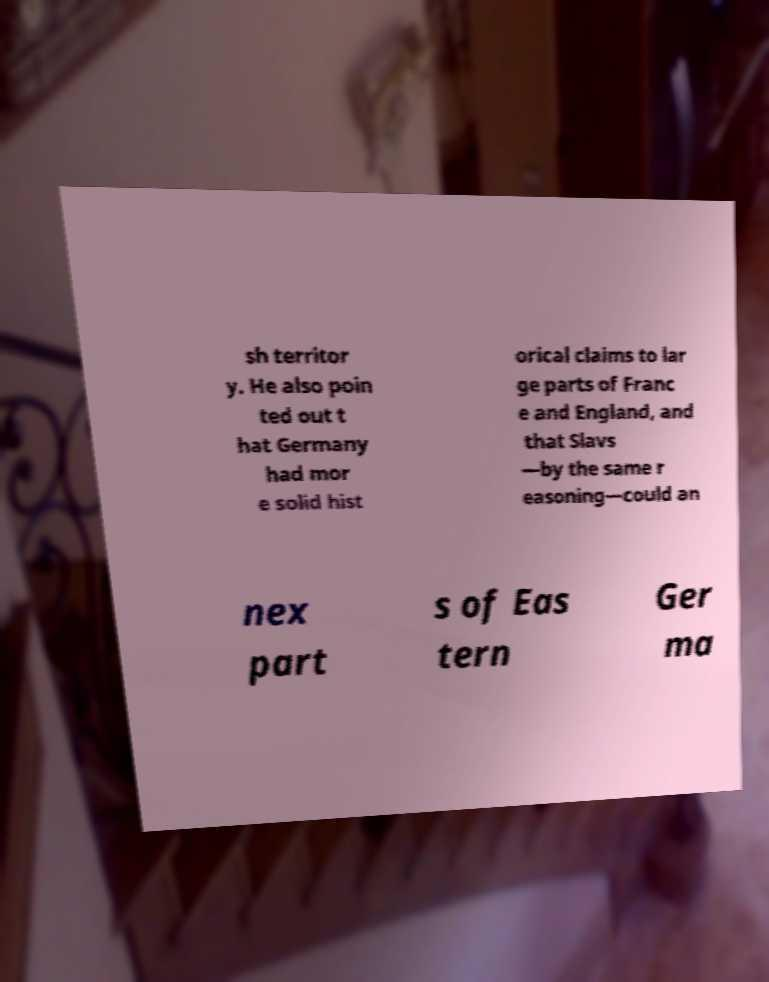Can you accurately transcribe the text from the provided image for me? sh territor y. He also poin ted out t hat Germany had mor e solid hist orical claims to lar ge parts of Franc e and England, and that Slavs —by the same r easoning—could an nex part s of Eas tern Ger ma 